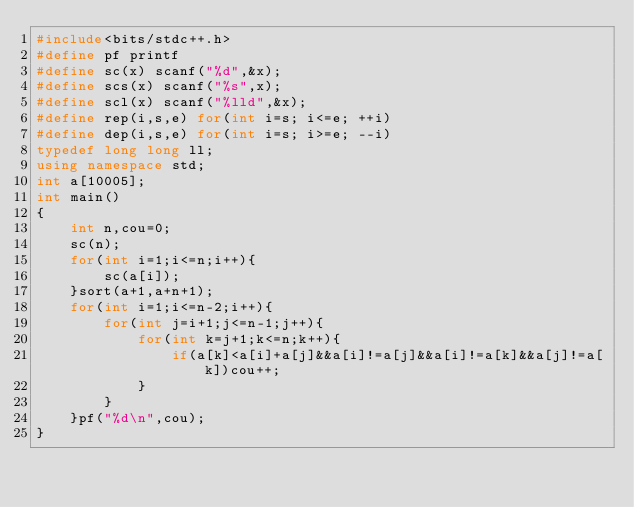Convert code to text. <code><loc_0><loc_0><loc_500><loc_500><_C++_>#include<bits/stdc++.h>
#define pf printf
#define sc(x) scanf("%d",&x);
#define scs(x) scanf("%s",x);
#define scl(x) scanf("%lld",&x);
#define rep(i,s,e) for(int i=s; i<=e; ++i)
#define dep(i,s,e) for(int i=s; i>=e; --i)
typedef long long ll;
using namespace std;
int	a[10005];
int main()
{
	int n,cou=0;
	sc(n);
	for(int i=1;i<=n;i++){
		sc(a[i]);
	}sort(a+1,a+n+1);
	for(int i=1;i<=n-2;i++){
		for(int j=i+1;j<=n-1;j++){
			for(int k=j+1;k<=n;k++){
				if(a[k]<a[i]+a[j]&&a[i]!=a[j]&&a[i]!=a[k]&&a[j]!=a[k])cou++;
			}
		}
	}pf("%d\n",cou);
}</code> 